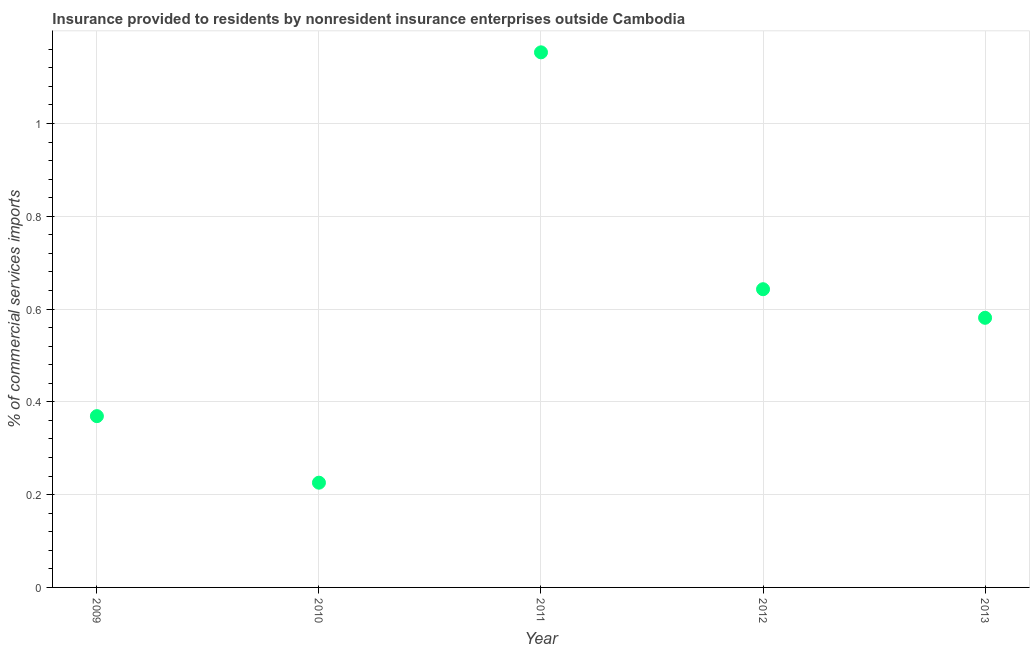What is the insurance provided by non-residents in 2010?
Give a very brief answer. 0.23. Across all years, what is the maximum insurance provided by non-residents?
Your answer should be compact. 1.15. Across all years, what is the minimum insurance provided by non-residents?
Offer a very short reply. 0.23. What is the sum of the insurance provided by non-residents?
Provide a succinct answer. 2.97. What is the difference between the insurance provided by non-residents in 2010 and 2013?
Provide a short and direct response. -0.36. What is the average insurance provided by non-residents per year?
Make the answer very short. 0.59. What is the median insurance provided by non-residents?
Keep it short and to the point. 0.58. In how many years, is the insurance provided by non-residents greater than 0.9600000000000001 %?
Offer a terse response. 1. What is the ratio of the insurance provided by non-residents in 2011 to that in 2012?
Your answer should be very brief. 1.79. Is the insurance provided by non-residents in 2011 less than that in 2013?
Your response must be concise. No. Is the difference between the insurance provided by non-residents in 2010 and 2013 greater than the difference between any two years?
Ensure brevity in your answer.  No. What is the difference between the highest and the second highest insurance provided by non-residents?
Your response must be concise. 0.51. What is the difference between the highest and the lowest insurance provided by non-residents?
Offer a very short reply. 0.93. In how many years, is the insurance provided by non-residents greater than the average insurance provided by non-residents taken over all years?
Your answer should be compact. 2. Does the insurance provided by non-residents monotonically increase over the years?
Your answer should be compact. No. How many dotlines are there?
Make the answer very short. 1. How many years are there in the graph?
Your answer should be very brief. 5. Are the values on the major ticks of Y-axis written in scientific E-notation?
Offer a terse response. No. Does the graph contain any zero values?
Give a very brief answer. No. Does the graph contain grids?
Give a very brief answer. Yes. What is the title of the graph?
Provide a short and direct response. Insurance provided to residents by nonresident insurance enterprises outside Cambodia. What is the label or title of the X-axis?
Your response must be concise. Year. What is the label or title of the Y-axis?
Your answer should be compact. % of commercial services imports. What is the % of commercial services imports in 2009?
Keep it short and to the point. 0.37. What is the % of commercial services imports in 2010?
Give a very brief answer. 0.23. What is the % of commercial services imports in 2011?
Provide a succinct answer. 1.15. What is the % of commercial services imports in 2012?
Your answer should be compact. 0.64. What is the % of commercial services imports in 2013?
Provide a short and direct response. 0.58. What is the difference between the % of commercial services imports in 2009 and 2010?
Make the answer very short. 0.14. What is the difference between the % of commercial services imports in 2009 and 2011?
Your answer should be compact. -0.78. What is the difference between the % of commercial services imports in 2009 and 2012?
Give a very brief answer. -0.27. What is the difference between the % of commercial services imports in 2009 and 2013?
Your answer should be compact. -0.21. What is the difference between the % of commercial services imports in 2010 and 2011?
Make the answer very short. -0.93. What is the difference between the % of commercial services imports in 2010 and 2012?
Ensure brevity in your answer.  -0.42. What is the difference between the % of commercial services imports in 2010 and 2013?
Give a very brief answer. -0.36. What is the difference between the % of commercial services imports in 2011 and 2012?
Your answer should be compact. 0.51. What is the difference between the % of commercial services imports in 2011 and 2013?
Your answer should be very brief. 0.57. What is the difference between the % of commercial services imports in 2012 and 2013?
Your answer should be very brief. 0.06. What is the ratio of the % of commercial services imports in 2009 to that in 2010?
Ensure brevity in your answer.  1.64. What is the ratio of the % of commercial services imports in 2009 to that in 2011?
Offer a terse response. 0.32. What is the ratio of the % of commercial services imports in 2009 to that in 2012?
Provide a short and direct response. 0.57. What is the ratio of the % of commercial services imports in 2009 to that in 2013?
Make the answer very short. 0.64. What is the ratio of the % of commercial services imports in 2010 to that in 2011?
Your answer should be compact. 0.2. What is the ratio of the % of commercial services imports in 2010 to that in 2012?
Your answer should be very brief. 0.35. What is the ratio of the % of commercial services imports in 2010 to that in 2013?
Give a very brief answer. 0.39. What is the ratio of the % of commercial services imports in 2011 to that in 2012?
Ensure brevity in your answer.  1.79. What is the ratio of the % of commercial services imports in 2011 to that in 2013?
Give a very brief answer. 1.99. What is the ratio of the % of commercial services imports in 2012 to that in 2013?
Your answer should be compact. 1.11. 